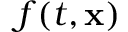<formula> <loc_0><loc_0><loc_500><loc_500>f ( t , x )</formula> 